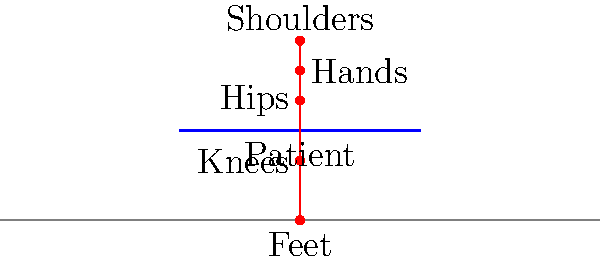In the diagram above, which biomechanical principle is demonstrated by the nurse's body positioning for proper patient lifting technique, and how does this positioning reduce the risk of back injury? The diagram demonstrates the proper biomechanical principle for patient lifting, which is maintaining a neutral spine position while using the legs to generate lifting force. This technique reduces the risk of back injury through several key steps:

1. Foot positioning: The nurse's feet are shoulder-width apart, providing a stable base of support.

2. Knee bending: The knees are bent, lowering the nurse's center of gravity and allowing the strong leg muscles to do the lifting.

3. Hip hinging: The hips are flexed, bringing the upper body closer to the patient while maintaining a straight back.

4. Neutral spine: The back is kept straight, maintaining its natural curves and avoiding excessive flexion or rotation.

5. Close proximity: The nurse is positioned close to the patient, minimizing the moment arm and reducing the torque on the spine.

6. Hand placement: The hands are placed at an appropriate height on the patient, allowing for a secure grip without excessive reaching.

This positioning utilizes the stronger leg muscles (quadriceps and gluteus maximus) for lifting, rather than relying on the smaller, more vulnerable muscles of the back. The neutral spine position distributes forces evenly along the vertebrae, reducing the risk of disc herniation or muscle strain.

The biomechanical advantage comes from the reduced moment arm (the perpendicular distance between the applied force and the axis of rotation). By keeping the patient close to the body and using proper leg positioning, the nurse minimizes the torque on the spine, which can be calculated using the equation:

$$\tau = F \times d$$

Where $\tau$ is torque, $F$ is the force (patient's weight), and $d$ is the moment arm.

By reducing $d$, the nurse significantly decreases the torque on their spine, lowering the risk of injury.
Answer: Neutral spine positioning with leg-driven lift 